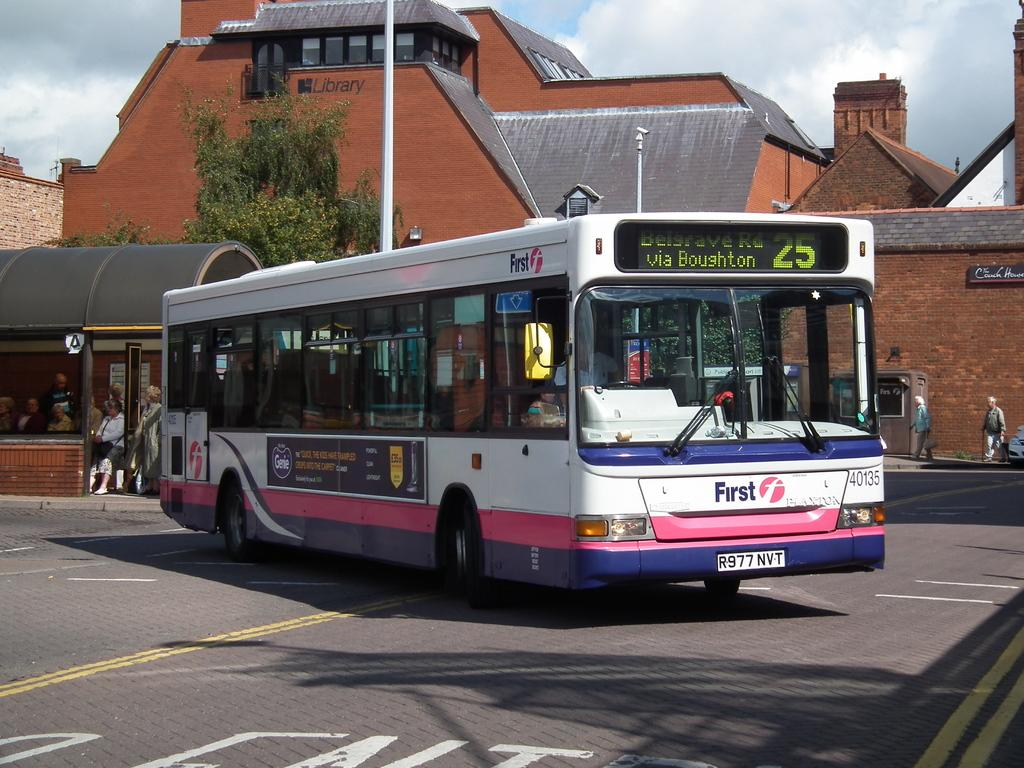Provide a one-sentence caption for the provided image. a city bus turning right and heading to via boughton. 